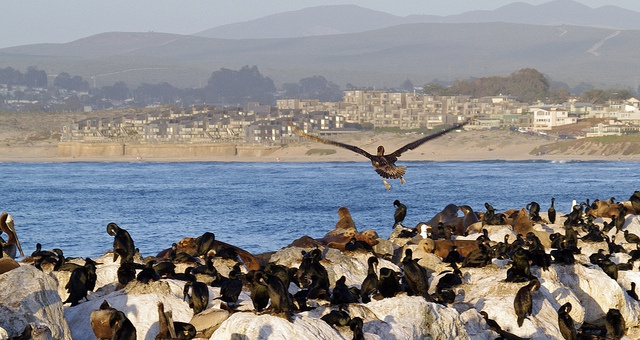Describe the objects in this image and their specific colors. I can see bird in lightgray, black, darkgray, and tan tones, bird in lightgray, black, gray, and maroon tones, bird in lightgray, black, olive, and maroon tones, bird in lightgray, black, and gray tones, and bird in lightgray, black, maroon, and gray tones in this image. 